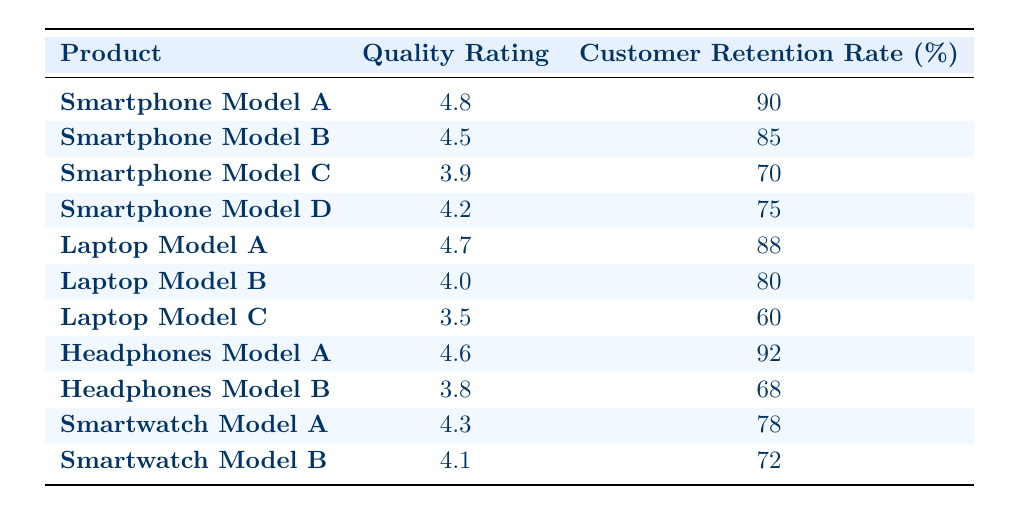What is the quality rating of Smartphone Model A? The table lists Smartphone Model A with a quality rating of 4.8 in the respective column.
Answer: 4.8 What is the customer retention rate of Headphones Model B? The table indicates that Headphones Model B has a customer retention rate of 68%.
Answer: 68% Which product has the highest customer retention rate? By examining the customer retention rates, Headphones Model A has the highest rate at 92%.
Answer: Headphones Model A What is the average quality rating of all Laptop models? The quality ratings for the Laptop models are 4.7, 4.0, and 3.5. Summing these gives 4.7 + 4.0 + 3.5 = 12.2. Dividing this by 3 (the number of Laptop models) results in an average of 12.2 / 3 = 4.07.
Answer: 4.07 Is it true that Smartphone Model C has a higher customer retention rate than Laptop Model B? Smartphone Model C has a retention rate of 70%, while Laptop Model B has a rate of 80%. Since 70% is less than 80%, the statement is false.
Answer: No What is the difference in customer retention rate between Laptop Model A and Smartwatch Model A? Laptop Model A has a retention rate of 88% and Smartwatch Model A has a rate of 78%. The difference is 88% - 78% = 10%.
Answer: 10% Which product corresponds to a quality rating of 4.2? Looking at the table, Smartphone Model D is the product that corresponds to a quality rating of 4.2.
Answer: Smartphone Model D Are there more products with a quality rating above 4.0 than those below 4.0? Counting the ratings, there are 7 products with ratings above 4.0 (Smartphone A, B, D; Laptop A, B; Headphones A; Smartwatch A) and 4 below (Smartphone C, Laptop C, Headphones B, Smartwatch B). Since 7 is greater than 4, the statement is true.
Answer: Yes What is the median customer retention rate of all products? To find the median, list the retention rates in order: 60, 68, 70, 72, 75, 78, 80, 85, 88, 90, 92. There are 11 rates, so the median is the 6th value, which is 78%.
Answer: 78% 